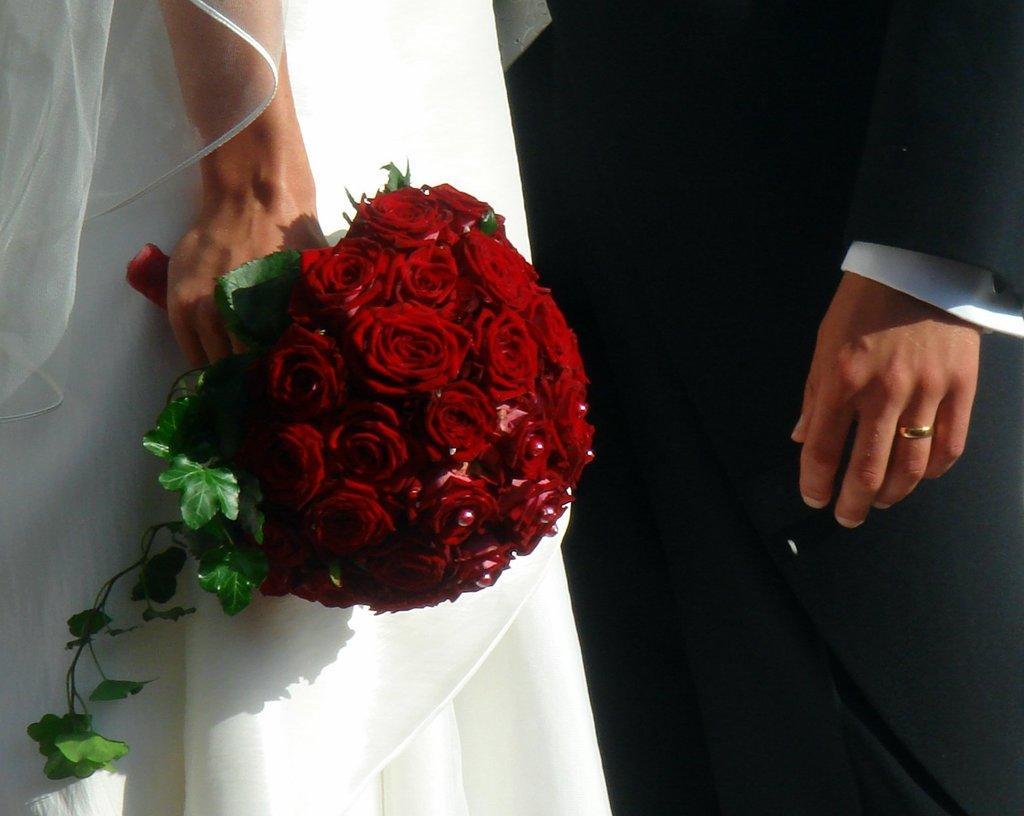Could you give a brief overview of what you see in this image? A couple is standing. The person at the left is wearing a white gown and veil and holding a red rose bouquet. The person at the right is wearing a black suit. 